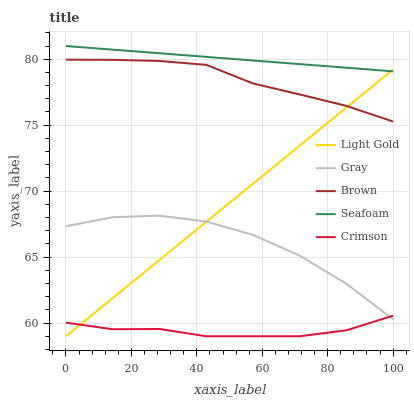Does Crimson have the minimum area under the curve?
Answer yes or no. Yes. Does Seafoam have the maximum area under the curve?
Answer yes or no. Yes. Does Gray have the minimum area under the curve?
Answer yes or no. No. Does Gray have the maximum area under the curve?
Answer yes or no. No. Is Seafoam the smoothest?
Answer yes or no. Yes. Is Gray the roughest?
Answer yes or no. Yes. Is Light Gold the smoothest?
Answer yes or no. No. Is Light Gold the roughest?
Answer yes or no. No. Does Crimson have the lowest value?
Answer yes or no. Yes. Does Gray have the lowest value?
Answer yes or no. No. Does Seafoam have the highest value?
Answer yes or no. Yes. Does Gray have the highest value?
Answer yes or no. No. Is Crimson less than Brown?
Answer yes or no. Yes. Is Brown greater than Gray?
Answer yes or no. Yes. Does Crimson intersect Gray?
Answer yes or no. Yes. Is Crimson less than Gray?
Answer yes or no. No. Is Crimson greater than Gray?
Answer yes or no. No. Does Crimson intersect Brown?
Answer yes or no. No. 